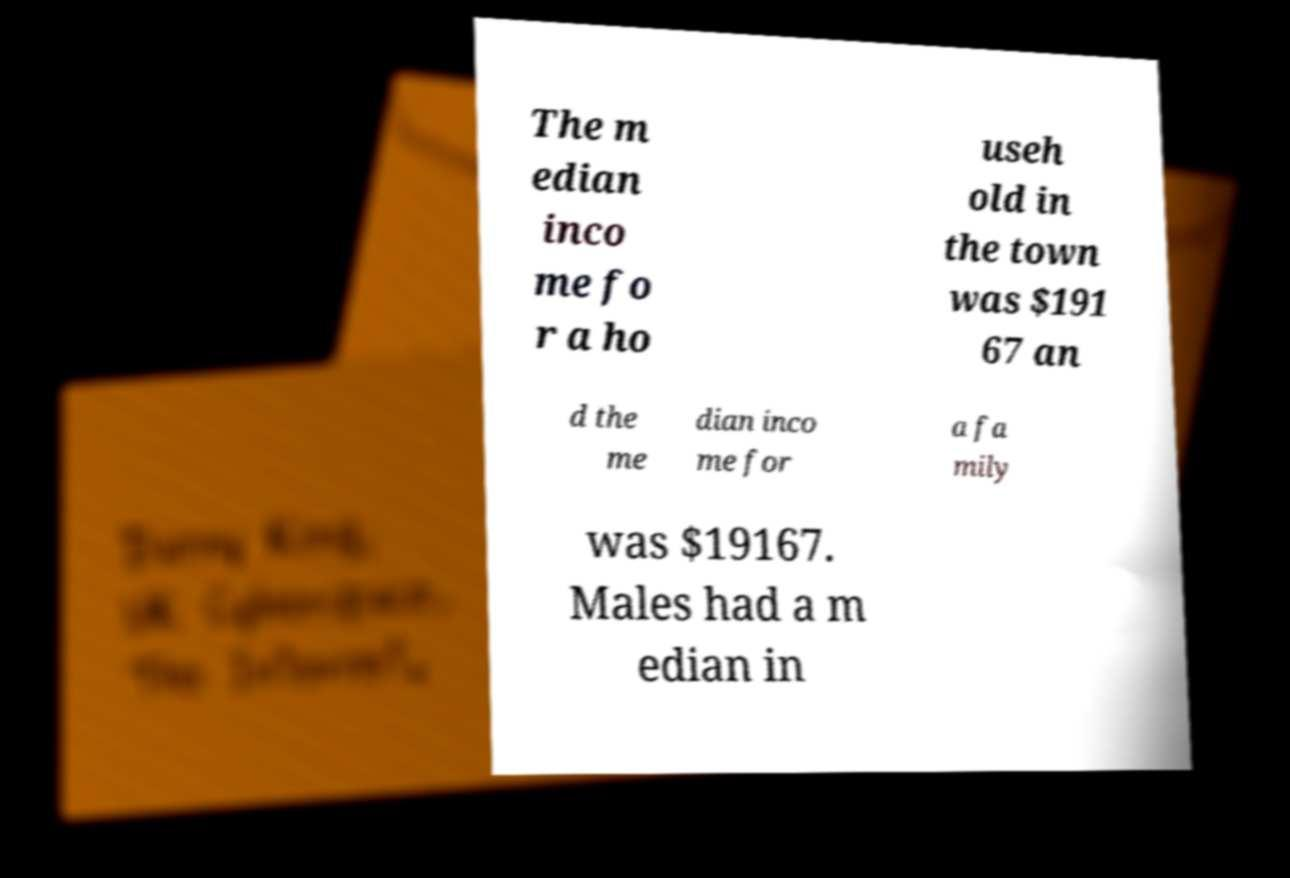Could you assist in decoding the text presented in this image and type it out clearly? The m edian inco me fo r a ho useh old in the town was $191 67 an d the me dian inco me for a fa mily was $19167. Males had a m edian in 